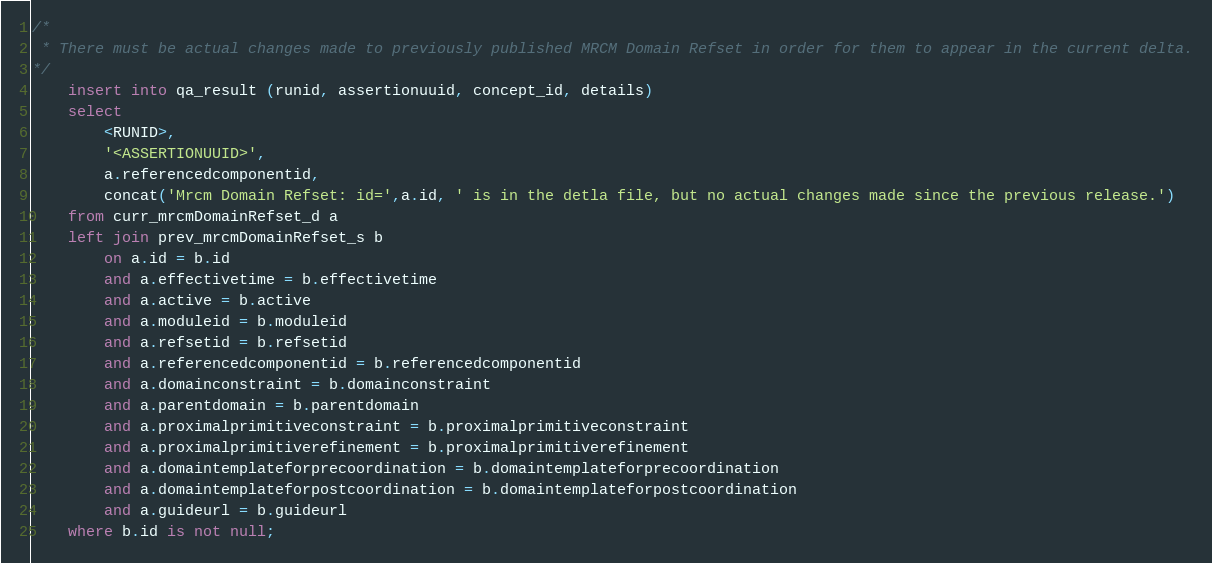Convert code to text. <code><loc_0><loc_0><loc_500><loc_500><_SQL_>/*  
 * There must be actual changes made to previously published MRCM Domain Refset in order for them to appear in the current delta.
*/
	insert into qa_result (runid, assertionuuid, concept_id, details)
	select 
		<RUNID>,
		'<ASSERTIONUUID>',
		a.referencedcomponentid,
		concat('Mrcm Domain Refset: id=',a.id, ' is in the detla file, but no actual changes made since the previous release.')
	from curr_mrcmDomainRefset_d a
	left join prev_mrcmDomainRefset_s b
		on a.id = b.id
		and a.effectivetime = b.effectivetime
		and a.active = b.active
		and a.moduleid = b.moduleid
		and a.refsetid = b.refsetid
		and a.referencedcomponentid = b.referencedcomponentid
		and a.domainconstraint = b.domainconstraint
		and a.parentdomain = b.parentdomain
		and a.proximalprimitiveconstraint = b.proximalprimitiveconstraint
		and a.proximalprimitiverefinement = b.proximalprimitiverefinement
		and a.domaintemplateforprecoordination = b.domaintemplateforprecoordination
		and a.domaintemplateforpostcoordination = b.domaintemplateforpostcoordination
		and a.guideurl = b.guideurl
	where b.id is not null;
</code> 